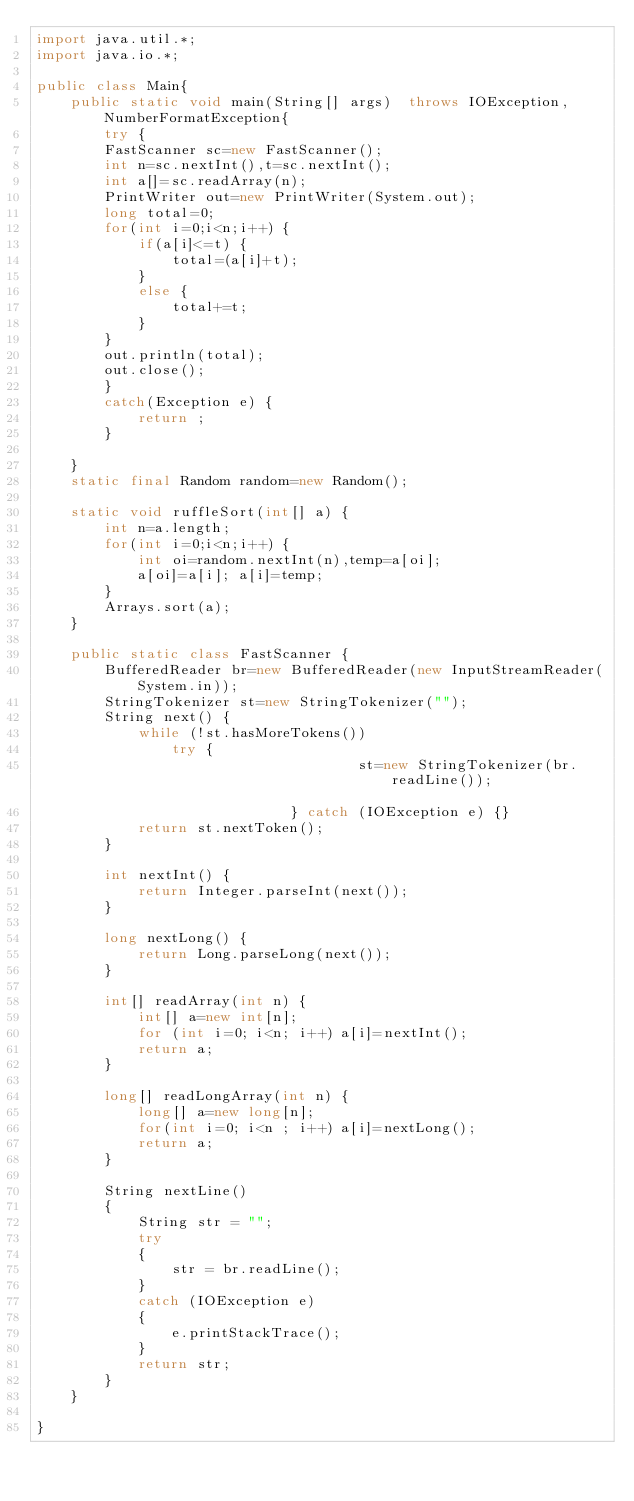<code> <loc_0><loc_0><loc_500><loc_500><_Java_>import java.util.*;
import java.io.*;

public class Main{
	public static void main(String[] args)  throws IOException,NumberFormatException{
		try {
		FastScanner sc=new FastScanner();
		int n=sc.nextInt(),t=sc.nextInt();
		int a[]=sc.readArray(n);
		PrintWriter out=new PrintWriter(System.out);
		long total=0;
		for(int i=0;i<n;i++) {
			if(a[i]<=t) {
				total=(a[i]+t);
			}
			else {
				total+=t;
			}
		}
		out.println(total);
		out.close();
		}
		catch(Exception e) {
			return ;
		}
		
	}
	static final Random random=new Random();
	
	static void ruffleSort(int[] a) {
		int n=a.length;
		for(int i=0;i<n;i++) {
			int oi=random.nextInt(n),temp=a[oi];
			a[oi]=a[i]; a[i]=temp;
		}
		Arrays.sort(a);
	}
	
	public static class FastScanner {
		BufferedReader br=new BufferedReader(new InputStreamReader(System.in));
		StringTokenizer st=new StringTokenizer("");
		String next() {
			while (!st.hasMoreTokens())
				try { 
                                      st=new StringTokenizer(br.readLine());				               
                              } catch (IOException e) {}
			return st.nextToken();
		}
		
		int nextInt() {
			return Integer.parseInt(next());
		}
		
		long nextLong() {
			return Long.parseLong(next());
		}
		
		int[] readArray(int n) {
			int[] a=new int[n];
			for (int i=0; i<n; i++) a[i]=nextInt();
			return a;
		}
		
		long[] readLongArray(int n) {
			long[] a=new long[n];
			for(int i=0; i<n ; i++) a[i]=nextLong();
			return a;
		}
		
		String nextLine() 
        { 
            String str = ""; 
            try
            { 
                str = br.readLine(); 
            } 
            catch (IOException e) 
            { 
                e.printStackTrace(); 
            } 
            return str; 
        } 
	}

}
</code> 